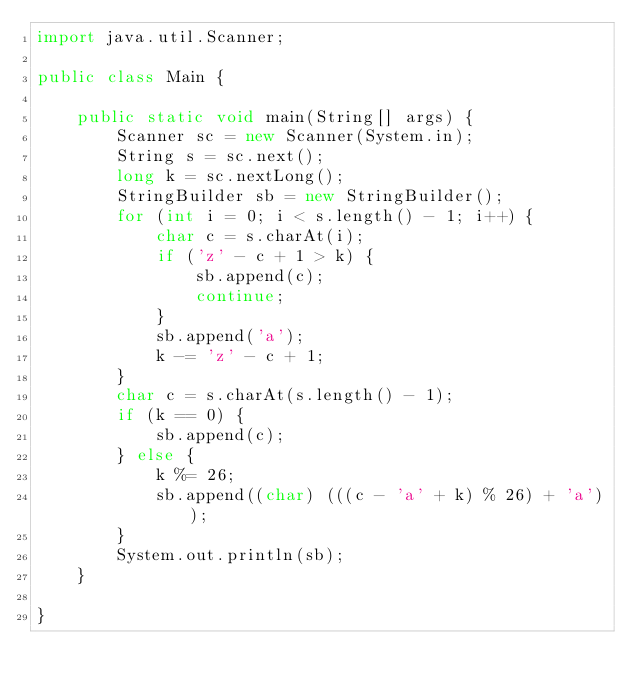Convert code to text. <code><loc_0><loc_0><loc_500><loc_500><_Java_>import java.util.Scanner;

public class Main {

    public static void main(String[] args) {
        Scanner sc = new Scanner(System.in);
        String s = sc.next();
        long k = sc.nextLong();
        StringBuilder sb = new StringBuilder();
        for (int i = 0; i < s.length() - 1; i++) {
            char c = s.charAt(i);
            if ('z' - c + 1 > k) {
                sb.append(c);
                continue;
            }
            sb.append('a');
            k -= 'z' - c + 1;
        }
        char c = s.charAt(s.length() - 1);
        if (k == 0) {
            sb.append(c);
        } else {
            k %= 26;
            sb.append((char) (((c - 'a' + k) % 26) + 'a'));
        }
        System.out.println(sb);
    }

}
</code> 